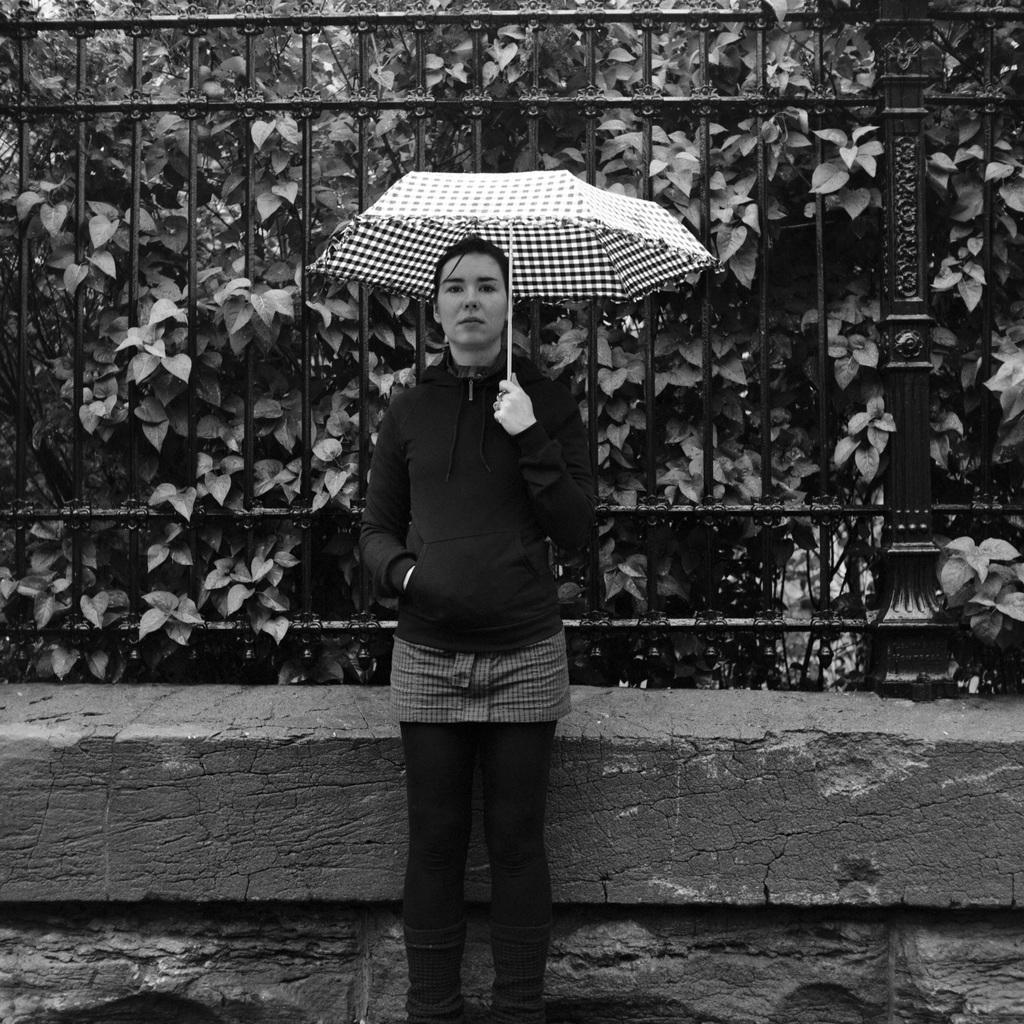Who is the main subject in the image? There is a woman in the image. What is the woman holding in the image? The woman is holding an umbrella. What type of material can be seen in the image? There are metal rods visible in the image. What type of vegetation is present in the image? There are trees in the image. What is the color scheme of the image? The image is in black and white. What type of prose is the woman reciting in the image? There is no indication in the image that the woman is reciting any prose. What type of pest can be seen crawling on the woman's arm in the image? There are no pests visible on the woman's arm in the image. 